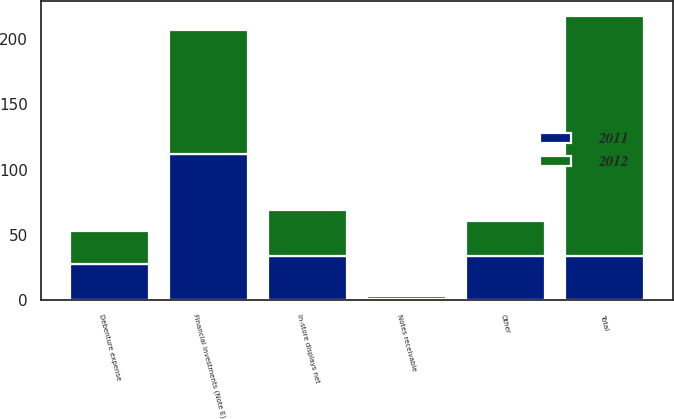Convert chart. <chart><loc_0><loc_0><loc_500><loc_500><stacked_bar_chart><ecel><fcel>Financial investments (Note E)<fcel>In-store displays net<fcel>Debenture expense<fcel>Notes receivable<fcel>Other<fcel>Total<nl><fcel>2012<fcel>95<fcel>35<fcel>25<fcel>2<fcel>27<fcel>184<nl><fcel>2011<fcel>112<fcel>34<fcel>28<fcel>1<fcel>34<fcel>34<nl></chart> 